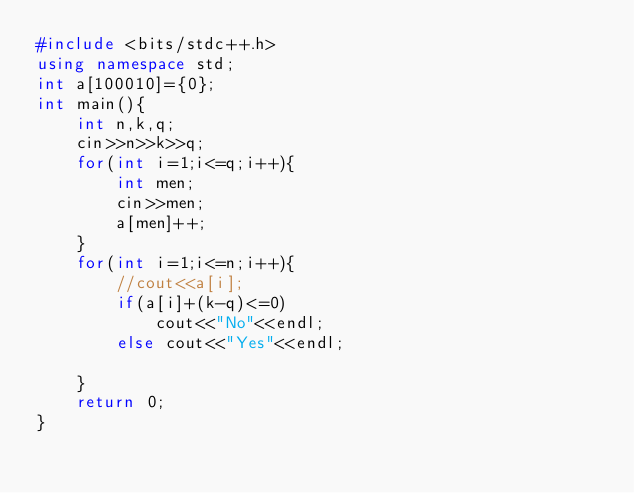Convert code to text. <code><loc_0><loc_0><loc_500><loc_500><_C++_>#include <bits/stdc++.h>
using namespace std;
int a[100010]={0};
int main(){
	int n,k,q;
	cin>>n>>k>>q;
	for(int i=1;i<=q;i++){
		int men;
		cin>>men;
		a[men]++; 
	}
	for(int i=1;i<=n;i++){
		//cout<<a[i]; 
		if(a[i]+(k-q)<=0) 
			cout<<"No"<<endl;
		else cout<<"Yes"<<endl;
		
	}
	return 0;
} </code> 